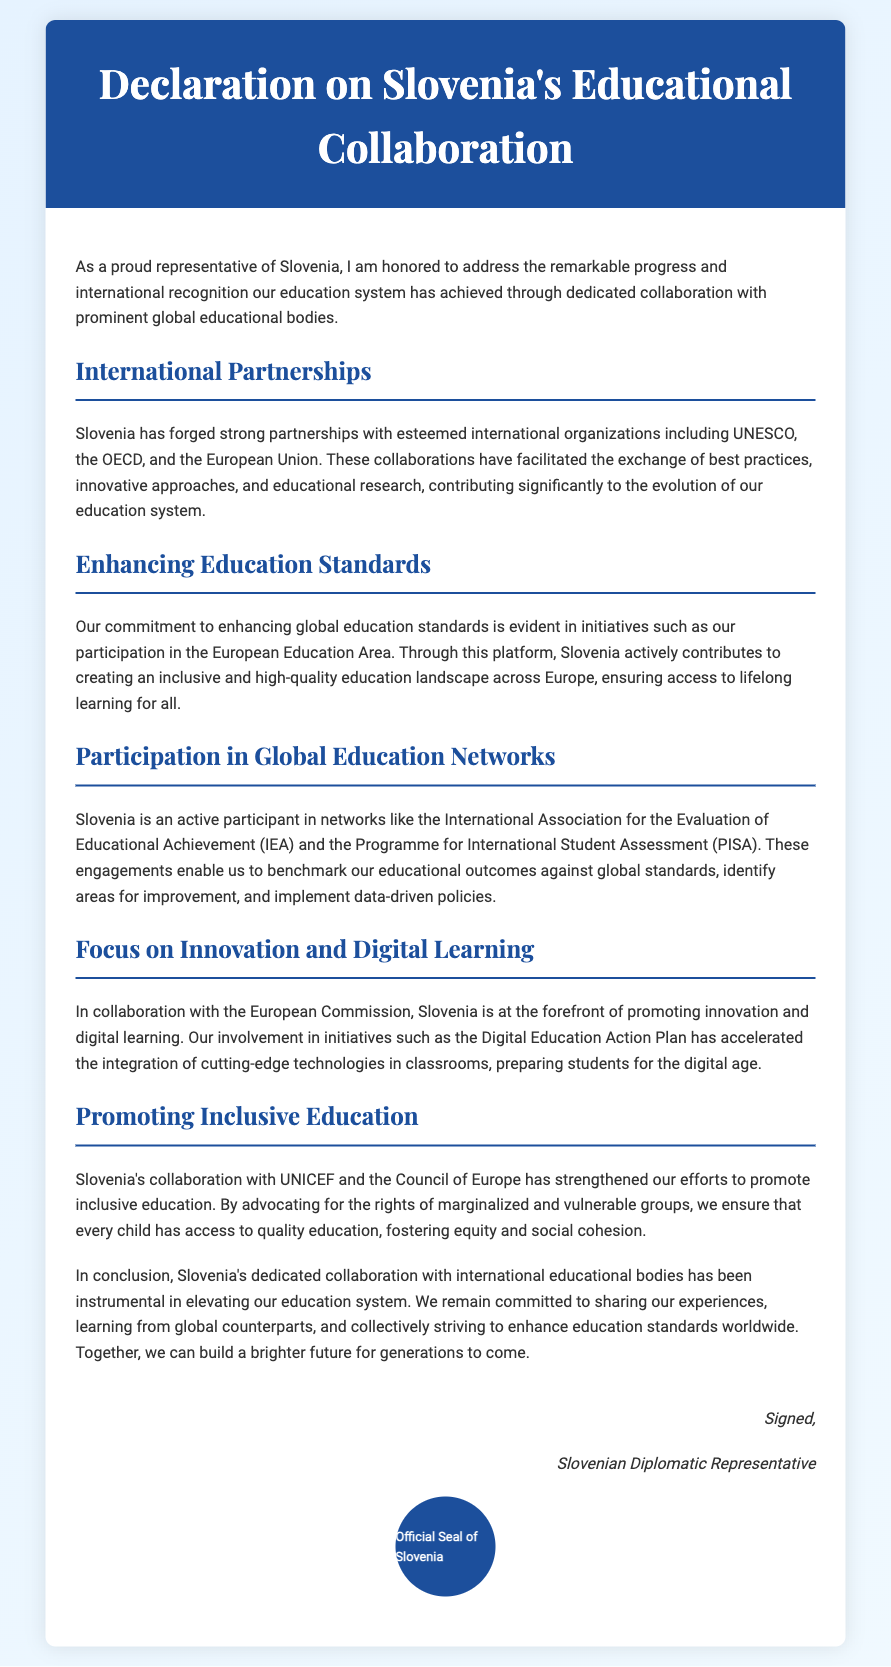What significant organizations has Slovenia partnered with? The significant organizations Slovenia has partnered with include UNESCO, the OECD, and the European Union.
Answer: UNESCO, OECD, European Union What initiative reflects Slovenia's commitment to enhancing education standards? The initiative reflecting Slovenia's commitment is participation in the European Education Area.
Answer: European Education Area Which global assessment does Slovenia participate in to evaluate educational outcomes? Slovenia participates in the Programme for International Student Assessment (PISA) to evaluate educational outcomes.
Answer: PISA What plan has Slovenia engaged in to promote digital learning? Slovenia is involved in the Digital Education Action Plan to promote digital learning.
Answer: Digital Education Action Plan What is a key focus of Slovenia's collaboration with UNICEF? A key focus is promoting inclusive education for marginalized and vulnerable groups.
Answer: Inclusive education How does Slovenia's collaboration influence educational policy? Slovenia's collaboration enables benchmarking against global standards, identifying areas for improvement, and implementing data-driven policies.
Answer: Benchmarking, data-driven policies What role does Slovenia aim to play in global education standards? Slovenia aims to share experiences and learn from global counterparts to enhance education standards worldwide.
Answer: Share experiences, enhance education standards Who signed the declaration? The declaration is signed by the Slovenian Diplomatic Representative.
Answer: Slovenian Diplomatic Representative 